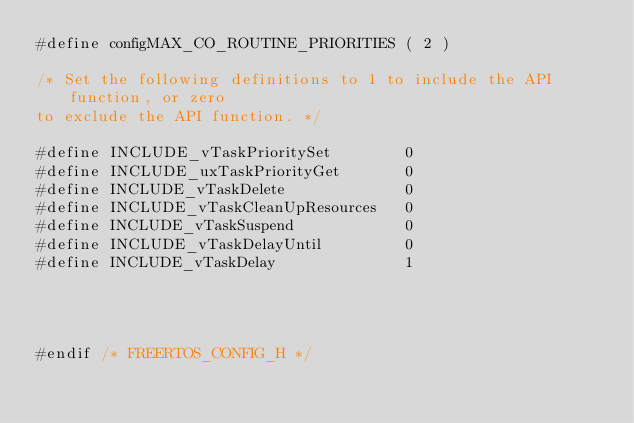Convert code to text. <code><loc_0><loc_0><loc_500><loc_500><_C_>#define configMAX_CO_ROUTINE_PRIORITIES ( 2 )

/* Set the following definitions to 1 to include the API function, or zero
to exclude the API function. */

#define INCLUDE_vTaskPrioritySet		0
#define INCLUDE_uxTaskPriorityGet		0
#define INCLUDE_vTaskDelete				0
#define INCLUDE_vTaskCleanUpResources	0
#define INCLUDE_vTaskSuspend			0
#define INCLUDE_vTaskDelayUntil			0
#define INCLUDE_vTaskDelay				1




#endif /* FREERTOS_CONFIG_H */
</code> 